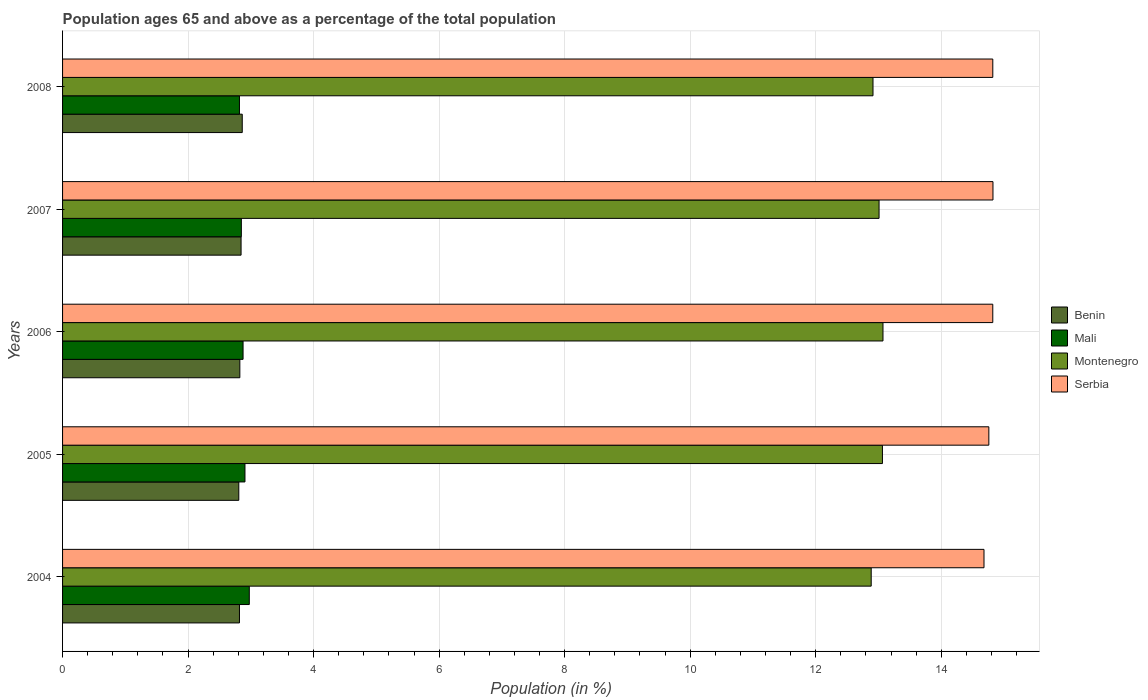How many different coloured bars are there?
Your answer should be compact. 4. How many bars are there on the 2nd tick from the top?
Offer a very short reply. 4. How many bars are there on the 4th tick from the bottom?
Provide a succinct answer. 4. What is the label of the 5th group of bars from the top?
Keep it short and to the point. 2004. In how many cases, is the number of bars for a given year not equal to the number of legend labels?
Offer a very short reply. 0. What is the percentage of the population ages 65 and above in Montenegro in 2007?
Keep it short and to the point. 13.01. Across all years, what is the maximum percentage of the population ages 65 and above in Mali?
Your response must be concise. 2.98. Across all years, what is the minimum percentage of the population ages 65 and above in Montenegro?
Make the answer very short. 12.88. In which year was the percentage of the population ages 65 and above in Mali minimum?
Your answer should be compact. 2008. What is the total percentage of the population ages 65 and above in Montenegro in the graph?
Provide a short and direct response. 64.94. What is the difference between the percentage of the population ages 65 and above in Montenegro in 2004 and that in 2007?
Your response must be concise. -0.13. What is the difference between the percentage of the population ages 65 and above in Mali in 2004 and the percentage of the population ages 65 and above in Montenegro in 2006?
Provide a short and direct response. -10.1. What is the average percentage of the population ages 65 and above in Mali per year?
Make the answer very short. 2.88. In the year 2004, what is the difference between the percentage of the population ages 65 and above in Mali and percentage of the population ages 65 and above in Serbia?
Your answer should be compact. -11.71. In how many years, is the percentage of the population ages 65 and above in Serbia greater than 3.6 ?
Ensure brevity in your answer.  5. What is the ratio of the percentage of the population ages 65 and above in Serbia in 2004 to that in 2007?
Offer a very short reply. 0.99. Is the percentage of the population ages 65 and above in Benin in 2005 less than that in 2008?
Offer a very short reply. Yes. Is the difference between the percentage of the population ages 65 and above in Mali in 2004 and 2008 greater than the difference between the percentage of the population ages 65 and above in Serbia in 2004 and 2008?
Provide a short and direct response. Yes. What is the difference between the highest and the second highest percentage of the population ages 65 and above in Serbia?
Offer a very short reply. 0. What is the difference between the highest and the lowest percentage of the population ages 65 and above in Montenegro?
Your answer should be very brief. 0.19. In how many years, is the percentage of the population ages 65 and above in Benin greater than the average percentage of the population ages 65 and above in Benin taken over all years?
Offer a terse response. 2. Is it the case that in every year, the sum of the percentage of the population ages 65 and above in Serbia and percentage of the population ages 65 and above in Benin is greater than the sum of percentage of the population ages 65 and above in Mali and percentage of the population ages 65 and above in Montenegro?
Offer a terse response. No. What does the 2nd bar from the top in 2004 represents?
Provide a succinct answer. Montenegro. What does the 2nd bar from the bottom in 2006 represents?
Your answer should be very brief. Mali. Are all the bars in the graph horizontal?
Ensure brevity in your answer.  Yes. Are the values on the major ticks of X-axis written in scientific E-notation?
Provide a short and direct response. No. Where does the legend appear in the graph?
Keep it short and to the point. Center right. How many legend labels are there?
Your answer should be compact. 4. What is the title of the graph?
Ensure brevity in your answer.  Population ages 65 and above as a percentage of the total population. What is the Population (in %) of Benin in 2004?
Keep it short and to the point. 2.82. What is the Population (in %) of Mali in 2004?
Provide a short and direct response. 2.98. What is the Population (in %) of Montenegro in 2004?
Make the answer very short. 12.88. What is the Population (in %) in Serbia in 2004?
Provide a succinct answer. 14.68. What is the Population (in %) in Benin in 2005?
Your answer should be very brief. 2.81. What is the Population (in %) in Mali in 2005?
Offer a terse response. 2.91. What is the Population (in %) in Montenegro in 2005?
Make the answer very short. 13.06. What is the Population (in %) in Serbia in 2005?
Your answer should be very brief. 14.76. What is the Population (in %) of Benin in 2006?
Give a very brief answer. 2.82. What is the Population (in %) of Mali in 2006?
Your answer should be compact. 2.88. What is the Population (in %) of Montenegro in 2006?
Provide a short and direct response. 13.07. What is the Population (in %) of Serbia in 2006?
Give a very brief answer. 14.82. What is the Population (in %) of Benin in 2007?
Ensure brevity in your answer.  2.84. What is the Population (in %) of Mali in 2007?
Provide a short and direct response. 2.85. What is the Population (in %) of Montenegro in 2007?
Provide a succinct answer. 13.01. What is the Population (in %) in Serbia in 2007?
Ensure brevity in your answer.  14.82. What is the Population (in %) in Benin in 2008?
Keep it short and to the point. 2.86. What is the Population (in %) in Mali in 2008?
Keep it short and to the point. 2.82. What is the Population (in %) in Montenegro in 2008?
Your answer should be very brief. 12.91. What is the Population (in %) in Serbia in 2008?
Give a very brief answer. 14.82. Across all years, what is the maximum Population (in %) in Benin?
Ensure brevity in your answer.  2.86. Across all years, what is the maximum Population (in %) in Mali?
Give a very brief answer. 2.98. Across all years, what is the maximum Population (in %) of Montenegro?
Your response must be concise. 13.07. Across all years, what is the maximum Population (in %) of Serbia?
Provide a succinct answer. 14.82. Across all years, what is the minimum Population (in %) of Benin?
Ensure brevity in your answer.  2.81. Across all years, what is the minimum Population (in %) in Mali?
Your answer should be very brief. 2.82. Across all years, what is the minimum Population (in %) of Montenegro?
Offer a terse response. 12.88. Across all years, what is the minimum Population (in %) in Serbia?
Ensure brevity in your answer.  14.68. What is the total Population (in %) in Benin in the graph?
Make the answer very short. 14.16. What is the total Population (in %) in Mali in the graph?
Ensure brevity in your answer.  14.42. What is the total Population (in %) in Montenegro in the graph?
Your answer should be compact. 64.94. What is the total Population (in %) in Serbia in the graph?
Offer a terse response. 73.91. What is the difference between the Population (in %) of Benin in 2004 and that in 2005?
Give a very brief answer. 0.01. What is the difference between the Population (in %) in Mali in 2004 and that in 2005?
Provide a short and direct response. 0.07. What is the difference between the Population (in %) in Montenegro in 2004 and that in 2005?
Your response must be concise. -0.18. What is the difference between the Population (in %) of Serbia in 2004 and that in 2005?
Provide a short and direct response. -0.08. What is the difference between the Population (in %) in Benin in 2004 and that in 2006?
Offer a very short reply. -0.01. What is the difference between the Population (in %) in Mali in 2004 and that in 2006?
Your answer should be very brief. 0.1. What is the difference between the Population (in %) of Montenegro in 2004 and that in 2006?
Your response must be concise. -0.19. What is the difference between the Population (in %) of Serbia in 2004 and that in 2006?
Provide a short and direct response. -0.14. What is the difference between the Population (in %) in Benin in 2004 and that in 2007?
Keep it short and to the point. -0.03. What is the difference between the Population (in %) of Mali in 2004 and that in 2007?
Make the answer very short. 0.13. What is the difference between the Population (in %) in Montenegro in 2004 and that in 2007?
Your response must be concise. -0.13. What is the difference between the Population (in %) of Serbia in 2004 and that in 2007?
Offer a very short reply. -0.14. What is the difference between the Population (in %) of Benin in 2004 and that in 2008?
Ensure brevity in your answer.  -0.04. What is the difference between the Population (in %) of Mali in 2004 and that in 2008?
Your answer should be very brief. 0.16. What is the difference between the Population (in %) in Montenegro in 2004 and that in 2008?
Ensure brevity in your answer.  -0.03. What is the difference between the Population (in %) of Serbia in 2004 and that in 2008?
Offer a very short reply. -0.14. What is the difference between the Population (in %) in Benin in 2005 and that in 2006?
Give a very brief answer. -0.02. What is the difference between the Population (in %) of Mali in 2005 and that in 2006?
Offer a very short reply. 0.03. What is the difference between the Population (in %) in Montenegro in 2005 and that in 2006?
Give a very brief answer. -0.01. What is the difference between the Population (in %) of Serbia in 2005 and that in 2006?
Your response must be concise. -0.06. What is the difference between the Population (in %) of Benin in 2005 and that in 2007?
Your answer should be compact. -0.04. What is the difference between the Population (in %) in Mali in 2005 and that in 2007?
Offer a very short reply. 0.06. What is the difference between the Population (in %) in Montenegro in 2005 and that in 2007?
Offer a very short reply. 0.05. What is the difference between the Population (in %) in Serbia in 2005 and that in 2007?
Offer a terse response. -0.07. What is the difference between the Population (in %) of Benin in 2005 and that in 2008?
Provide a succinct answer. -0.05. What is the difference between the Population (in %) in Mali in 2005 and that in 2008?
Your response must be concise. 0.09. What is the difference between the Population (in %) in Montenegro in 2005 and that in 2008?
Offer a terse response. 0.15. What is the difference between the Population (in %) in Serbia in 2005 and that in 2008?
Your answer should be very brief. -0.06. What is the difference between the Population (in %) in Benin in 2006 and that in 2007?
Your answer should be very brief. -0.02. What is the difference between the Population (in %) of Mali in 2006 and that in 2007?
Make the answer very short. 0.03. What is the difference between the Population (in %) in Montenegro in 2006 and that in 2007?
Ensure brevity in your answer.  0.06. What is the difference between the Population (in %) of Serbia in 2006 and that in 2007?
Ensure brevity in your answer.  -0. What is the difference between the Population (in %) of Benin in 2006 and that in 2008?
Offer a terse response. -0.04. What is the difference between the Population (in %) of Mali in 2006 and that in 2008?
Your answer should be compact. 0.06. What is the difference between the Population (in %) in Montenegro in 2006 and that in 2008?
Ensure brevity in your answer.  0.16. What is the difference between the Population (in %) of Serbia in 2006 and that in 2008?
Make the answer very short. -0. What is the difference between the Population (in %) of Benin in 2007 and that in 2008?
Offer a terse response. -0.02. What is the difference between the Population (in %) in Mali in 2007 and that in 2008?
Make the answer very short. 0.03. What is the difference between the Population (in %) of Montenegro in 2007 and that in 2008?
Make the answer very short. 0.1. What is the difference between the Population (in %) of Serbia in 2007 and that in 2008?
Your response must be concise. 0. What is the difference between the Population (in %) of Benin in 2004 and the Population (in %) of Mali in 2005?
Give a very brief answer. -0.09. What is the difference between the Population (in %) of Benin in 2004 and the Population (in %) of Montenegro in 2005?
Keep it short and to the point. -10.24. What is the difference between the Population (in %) in Benin in 2004 and the Population (in %) in Serbia in 2005?
Give a very brief answer. -11.94. What is the difference between the Population (in %) of Mali in 2004 and the Population (in %) of Montenegro in 2005?
Make the answer very short. -10.09. What is the difference between the Population (in %) in Mali in 2004 and the Population (in %) in Serbia in 2005?
Provide a short and direct response. -11.78. What is the difference between the Population (in %) in Montenegro in 2004 and the Population (in %) in Serbia in 2005?
Give a very brief answer. -1.87. What is the difference between the Population (in %) of Benin in 2004 and the Population (in %) of Mali in 2006?
Give a very brief answer. -0.06. What is the difference between the Population (in %) of Benin in 2004 and the Population (in %) of Montenegro in 2006?
Keep it short and to the point. -10.25. What is the difference between the Population (in %) in Benin in 2004 and the Population (in %) in Serbia in 2006?
Ensure brevity in your answer.  -12. What is the difference between the Population (in %) of Mali in 2004 and the Population (in %) of Montenegro in 2006?
Offer a terse response. -10.1. What is the difference between the Population (in %) in Mali in 2004 and the Population (in %) in Serbia in 2006?
Provide a short and direct response. -11.85. What is the difference between the Population (in %) in Montenegro in 2004 and the Population (in %) in Serbia in 2006?
Provide a short and direct response. -1.94. What is the difference between the Population (in %) in Benin in 2004 and the Population (in %) in Mali in 2007?
Provide a succinct answer. -0.03. What is the difference between the Population (in %) in Benin in 2004 and the Population (in %) in Montenegro in 2007?
Provide a succinct answer. -10.19. What is the difference between the Population (in %) of Benin in 2004 and the Population (in %) of Serbia in 2007?
Keep it short and to the point. -12.01. What is the difference between the Population (in %) in Mali in 2004 and the Population (in %) in Montenegro in 2007?
Make the answer very short. -10.03. What is the difference between the Population (in %) of Mali in 2004 and the Population (in %) of Serbia in 2007?
Make the answer very short. -11.85. What is the difference between the Population (in %) of Montenegro in 2004 and the Population (in %) of Serbia in 2007?
Ensure brevity in your answer.  -1.94. What is the difference between the Population (in %) of Benin in 2004 and the Population (in %) of Montenegro in 2008?
Offer a very short reply. -10.09. What is the difference between the Population (in %) in Benin in 2004 and the Population (in %) in Serbia in 2008?
Keep it short and to the point. -12. What is the difference between the Population (in %) of Mali in 2004 and the Population (in %) of Montenegro in 2008?
Provide a succinct answer. -9.94. What is the difference between the Population (in %) of Mali in 2004 and the Population (in %) of Serbia in 2008?
Offer a terse response. -11.85. What is the difference between the Population (in %) in Montenegro in 2004 and the Population (in %) in Serbia in 2008?
Offer a very short reply. -1.94. What is the difference between the Population (in %) of Benin in 2005 and the Population (in %) of Mali in 2006?
Your response must be concise. -0.07. What is the difference between the Population (in %) of Benin in 2005 and the Population (in %) of Montenegro in 2006?
Your answer should be compact. -10.26. What is the difference between the Population (in %) of Benin in 2005 and the Population (in %) of Serbia in 2006?
Your answer should be very brief. -12.01. What is the difference between the Population (in %) in Mali in 2005 and the Population (in %) in Montenegro in 2006?
Your answer should be very brief. -10.17. What is the difference between the Population (in %) in Mali in 2005 and the Population (in %) in Serbia in 2006?
Your response must be concise. -11.92. What is the difference between the Population (in %) of Montenegro in 2005 and the Population (in %) of Serbia in 2006?
Give a very brief answer. -1.76. What is the difference between the Population (in %) in Benin in 2005 and the Population (in %) in Mali in 2007?
Make the answer very short. -0.04. What is the difference between the Population (in %) of Benin in 2005 and the Population (in %) of Montenegro in 2007?
Keep it short and to the point. -10.2. What is the difference between the Population (in %) of Benin in 2005 and the Population (in %) of Serbia in 2007?
Provide a succinct answer. -12.02. What is the difference between the Population (in %) in Mali in 2005 and the Population (in %) in Montenegro in 2007?
Your answer should be compact. -10.1. What is the difference between the Population (in %) of Mali in 2005 and the Population (in %) of Serbia in 2007?
Offer a very short reply. -11.92. What is the difference between the Population (in %) in Montenegro in 2005 and the Population (in %) in Serbia in 2007?
Ensure brevity in your answer.  -1.76. What is the difference between the Population (in %) of Benin in 2005 and the Population (in %) of Mali in 2008?
Offer a terse response. -0.01. What is the difference between the Population (in %) in Benin in 2005 and the Population (in %) in Montenegro in 2008?
Provide a succinct answer. -10.11. What is the difference between the Population (in %) of Benin in 2005 and the Population (in %) of Serbia in 2008?
Offer a very short reply. -12.01. What is the difference between the Population (in %) in Mali in 2005 and the Population (in %) in Montenegro in 2008?
Provide a short and direct response. -10.01. What is the difference between the Population (in %) in Mali in 2005 and the Population (in %) in Serbia in 2008?
Offer a terse response. -11.92. What is the difference between the Population (in %) in Montenegro in 2005 and the Population (in %) in Serbia in 2008?
Your answer should be very brief. -1.76. What is the difference between the Population (in %) of Benin in 2006 and the Population (in %) of Mali in 2007?
Your response must be concise. -0.02. What is the difference between the Population (in %) of Benin in 2006 and the Population (in %) of Montenegro in 2007?
Provide a succinct answer. -10.18. What is the difference between the Population (in %) of Benin in 2006 and the Population (in %) of Serbia in 2007?
Offer a terse response. -12. What is the difference between the Population (in %) of Mali in 2006 and the Population (in %) of Montenegro in 2007?
Your answer should be very brief. -10.13. What is the difference between the Population (in %) of Mali in 2006 and the Population (in %) of Serbia in 2007?
Provide a succinct answer. -11.95. What is the difference between the Population (in %) of Montenegro in 2006 and the Population (in %) of Serbia in 2007?
Give a very brief answer. -1.75. What is the difference between the Population (in %) of Benin in 2006 and the Population (in %) of Mali in 2008?
Your answer should be very brief. 0.01. What is the difference between the Population (in %) in Benin in 2006 and the Population (in %) in Montenegro in 2008?
Offer a terse response. -10.09. What is the difference between the Population (in %) in Benin in 2006 and the Population (in %) in Serbia in 2008?
Provide a succinct answer. -12. What is the difference between the Population (in %) of Mali in 2006 and the Population (in %) of Montenegro in 2008?
Your answer should be compact. -10.04. What is the difference between the Population (in %) of Mali in 2006 and the Population (in %) of Serbia in 2008?
Your response must be concise. -11.95. What is the difference between the Population (in %) of Montenegro in 2006 and the Population (in %) of Serbia in 2008?
Provide a short and direct response. -1.75. What is the difference between the Population (in %) in Benin in 2007 and the Population (in %) in Mali in 2008?
Give a very brief answer. 0.03. What is the difference between the Population (in %) of Benin in 2007 and the Population (in %) of Montenegro in 2008?
Give a very brief answer. -10.07. What is the difference between the Population (in %) in Benin in 2007 and the Population (in %) in Serbia in 2008?
Offer a terse response. -11.98. What is the difference between the Population (in %) of Mali in 2007 and the Population (in %) of Montenegro in 2008?
Your response must be concise. -10.06. What is the difference between the Population (in %) in Mali in 2007 and the Population (in %) in Serbia in 2008?
Your answer should be very brief. -11.97. What is the difference between the Population (in %) in Montenegro in 2007 and the Population (in %) in Serbia in 2008?
Your answer should be compact. -1.81. What is the average Population (in %) in Benin per year?
Offer a very short reply. 2.83. What is the average Population (in %) in Mali per year?
Your answer should be very brief. 2.88. What is the average Population (in %) of Montenegro per year?
Offer a very short reply. 12.99. What is the average Population (in %) in Serbia per year?
Give a very brief answer. 14.78. In the year 2004, what is the difference between the Population (in %) of Benin and Population (in %) of Mali?
Your answer should be very brief. -0.16. In the year 2004, what is the difference between the Population (in %) of Benin and Population (in %) of Montenegro?
Provide a succinct answer. -10.07. In the year 2004, what is the difference between the Population (in %) in Benin and Population (in %) in Serbia?
Offer a terse response. -11.86. In the year 2004, what is the difference between the Population (in %) in Mali and Population (in %) in Montenegro?
Keep it short and to the point. -9.91. In the year 2004, what is the difference between the Population (in %) of Mali and Population (in %) of Serbia?
Offer a terse response. -11.71. In the year 2004, what is the difference between the Population (in %) in Montenegro and Population (in %) in Serbia?
Make the answer very short. -1.8. In the year 2005, what is the difference between the Population (in %) in Benin and Population (in %) in Mali?
Your answer should be compact. -0.1. In the year 2005, what is the difference between the Population (in %) in Benin and Population (in %) in Montenegro?
Your answer should be very brief. -10.26. In the year 2005, what is the difference between the Population (in %) of Benin and Population (in %) of Serbia?
Ensure brevity in your answer.  -11.95. In the year 2005, what is the difference between the Population (in %) in Mali and Population (in %) in Montenegro?
Offer a terse response. -10.16. In the year 2005, what is the difference between the Population (in %) of Mali and Population (in %) of Serbia?
Give a very brief answer. -11.85. In the year 2005, what is the difference between the Population (in %) of Montenegro and Population (in %) of Serbia?
Provide a succinct answer. -1.7. In the year 2006, what is the difference between the Population (in %) in Benin and Population (in %) in Mali?
Keep it short and to the point. -0.05. In the year 2006, what is the difference between the Population (in %) of Benin and Population (in %) of Montenegro?
Offer a very short reply. -10.25. In the year 2006, what is the difference between the Population (in %) of Benin and Population (in %) of Serbia?
Your answer should be compact. -12. In the year 2006, what is the difference between the Population (in %) of Mali and Population (in %) of Montenegro?
Your answer should be very brief. -10.2. In the year 2006, what is the difference between the Population (in %) of Mali and Population (in %) of Serbia?
Make the answer very short. -11.95. In the year 2006, what is the difference between the Population (in %) of Montenegro and Population (in %) of Serbia?
Give a very brief answer. -1.75. In the year 2007, what is the difference between the Population (in %) of Benin and Population (in %) of Mali?
Your answer should be compact. -0. In the year 2007, what is the difference between the Population (in %) in Benin and Population (in %) in Montenegro?
Ensure brevity in your answer.  -10.17. In the year 2007, what is the difference between the Population (in %) of Benin and Population (in %) of Serbia?
Your response must be concise. -11.98. In the year 2007, what is the difference between the Population (in %) in Mali and Population (in %) in Montenegro?
Provide a succinct answer. -10.16. In the year 2007, what is the difference between the Population (in %) of Mali and Population (in %) of Serbia?
Keep it short and to the point. -11.98. In the year 2007, what is the difference between the Population (in %) in Montenegro and Population (in %) in Serbia?
Make the answer very short. -1.82. In the year 2008, what is the difference between the Population (in %) in Benin and Population (in %) in Mali?
Give a very brief answer. 0.04. In the year 2008, what is the difference between the Population (in %) of Benin and Population (in %) of Montenegro?
Keep it short and to the point. -10.05. In the year 2008, what is the difference between the Population (in %) of Benin and Population (in %) of Serbia?
Provide a succinct answer. -11.96. In the year 2008, what is the difference between the Population (in %) of Mali and Population (in %) of Montenegro?
Give a very brief answer. -10.09. In the year 2008, what is the difference between the Population (in %) in Mali and Population (in %) in Serbia?
Your answer should be very brief. -12. In the year 2008, what is the difference between the Population (in %) in Montenegro and Population (in %) in Serbia?
Ensure brevity in your answer.  -1.91. What is the ratio of the Population (in %) of Benin in 2004 to that in 2005?
Your response must be concise. 1. What is the ratio of the Population (in %) of Mali in 2004 to that in 2005?
Provide a short and direct response. 1.02. What is the ratio of the Population (in %) in Montenegro in 2004 to that in 2005?
Your answer should be very brief. 0.99. What is the ratio of the Population (in %) in Benin in 2004 to that in 2006?
Offer a very short reply. 1. What is the ratio of the Population (in %) of Mali in 2004 to that in 2006?
Your answer should be very brief. 1.03. What is the ratio of the Population (in %) in Montenegro in 2004 to that in 2006?
Ensure brevity in your answer.  0.99. What is the ratio of the Population (in %) in Serbia in 2004 to that in 2006?
Offer a very short reply. 0.99. What is the ratio of the Population (in %) in Benin in 2004 to that in 2007?
Provide a succinct answer. 0.99. What is the ratio of the Population (in %) in Mali in 2004 to that in 2007?
Your answer should be compact. 1.04. What is the ratio of the Population (in %) in Montenegro in 2004 to that in 2007?
Your answer should be very brief. 0.99. What is the ratio of the Population (in %) in Serbia in 2004 to that in 2007?
Ensure brevity in your answer.  0.99. What is the ratio of the Population (in %) in Benin in 2004 to that in 2008?
Your answer should be very brief. 0.98. What is the ratio of the Population (in %) of Mali in 2004 to that in 2008?
Provide a succinct answer. 1.06. What is the ratio of the Population (in %) in Serbia in 2004 to that in 2008?
Your answer should be compact. 0.99. What is the ratio of the Population (in %) in Benin in 2005 to that in 2006?
Your response must be concise. 0.99. What is the ratio of the Population (in %) in Mali in 2005 to that in 2006?
Your response must be concise. 1.01. What is the ratio of the Population (in %) of Montenegro in 2005 to that in 2006?
Keep it short and to the point. 1. What is the ratio of the Population (in %) of Serbia in 2005 to that in 2006?
Offer a terse response. 1. What is the ratio of the Population (in %) in Benin in 2005 to that in 2007?
Make the answer very short. 0.99. What is the ratio of the Population (in %) of Mali in 2005 to that in 2007?
Give a very brief answer. 1.02. What is the ratio of the Population (in %) in Montenegro in 2005 to that in 2007?
Ensure brevity in your answer.  1. What is the ratio of the Population (in %) of Benin in 2005 to that in 2008?
Offer a terse response. 0.98. What is the ratio of the Population (in %) of Mali in 2005 to that in 2008?
Your answer should be very brief. 1.03. What is the ratio of the Population (in %) of Montenegro in 2005 to that in 2008?
Give a very brief answer. 1.01. What is the ratio of the Population (in %) of Serbia in 2005 to that in 2008?
Keep it short and to the point. 1. What is the ratio of the Population (in %) of Benin in 2006 to that in 2007?
Keep it short and to the point. 0.99. What is the ratio of the Population (in %) in Mali in 2006 to that in 2007?
Offer a very short reply. 1.01. What is the ratio of the Population (in %) of Benin in 2006 to that in 2008?
Provide a succinct answer. 0.99. What is the ratio of the Population (in %) of Mali in 2006 to that in 2008?
Offer a terse response. 1.02. What is the ratio of the Population (in %) in Montenegro in 2006 to that in 2008?
Offer a terse response. 1.01. What is the ratio of the Population (in %) of Benin in 2007 to that in 2008?
Give a very brief answer. 0.99. What is the ratio of the Population (in %) of Mali in 2007 to that in 2008?
Make the answer very short. 1.01. What is the ratio of the Population (in %) in Montenegro in 2007 to that in 2008?
Offer a terse response. 1.01. What is the ratio of the Population (in %) of Serbia in 2007 to that in 2008?
Your answer should be compact. 1. What is the difference between the highest and the second highest Population (in %) of Benin?
Give a very brief answer. 0.02. What is the difference between the highest and the second highest Population (in %) in Mali?
Your answer should be very brief. 0.07. What is the difference between the highest and the second highest Population (in %) of Montenegro?
Offer a very short reply. 0.01. What is the difference between the highest and the second highest Population (in %) of Serbia?
Your response must be concise. 0. What is the difference between the highest and the lowest Population (in %) in Benin?
Offer a terse response. 0.05. What is the difference between the highest and the lowest Population (in %) of Mali?
Make the answer very short. 0.16. What is the difference between the highest and the lowest Population (in %) of Montenegro?
Provide a succinct answer. 0.19. What is the difference between the highest and the lowest Population (in %) of Serbia?
Keep it short and to the point. 0.14. 